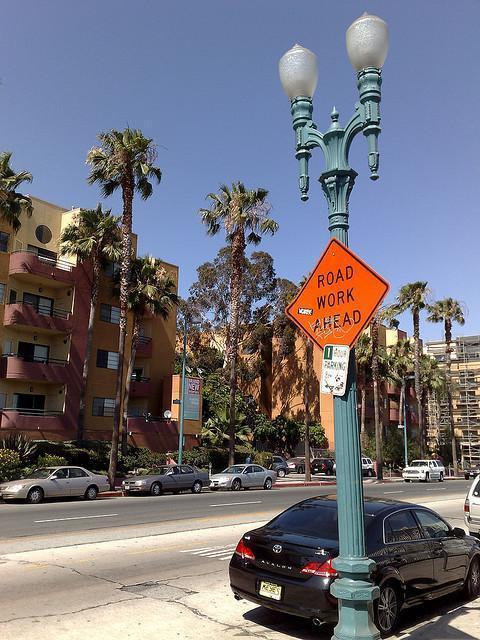How many numbers are on the signs on the light pole?
Give a very brief answer. 1. How many stories is the building?
Give a very brief answer. 4. How many cars are visible?
Give a very brief answer. 2. 